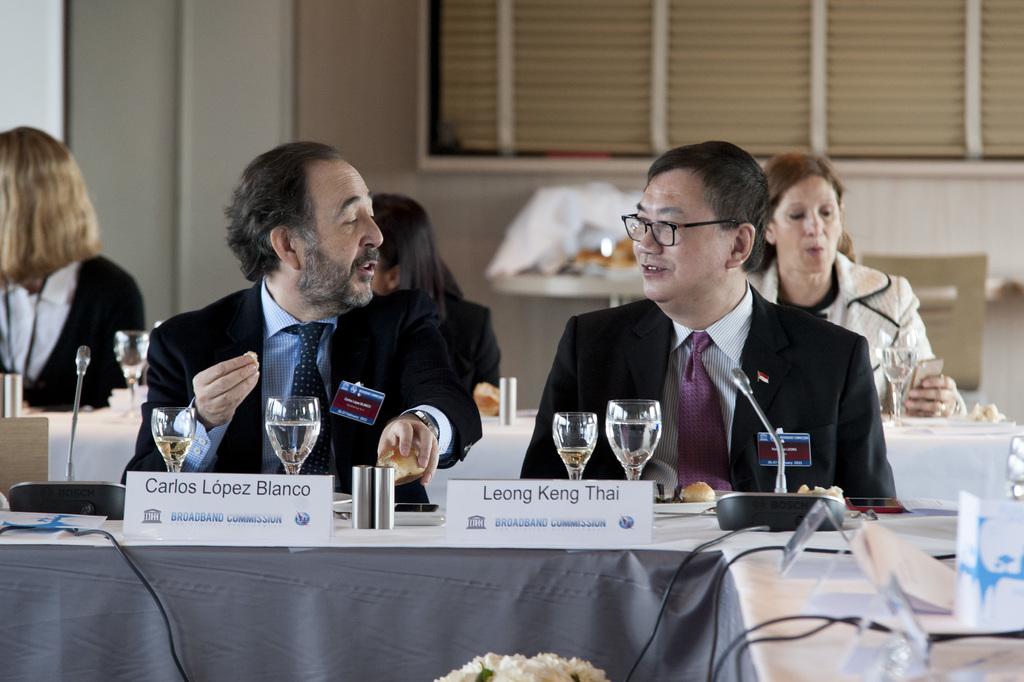What is the first name of the person on the left?
Offer a terse response. Carlos. Carlos lopez blanco?
Offer a very short reply. Yes. 